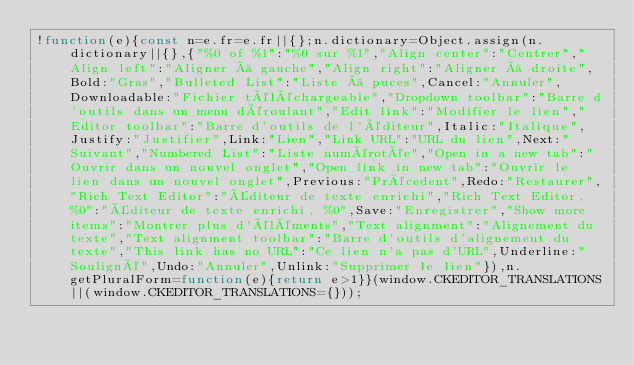<code> <loc_0><loc_0><loc_500><loc_500><_JavaScript_>!function(e){const n=e.fr=e.fr||{};n.dictionary=Object.assign(n.dictionary||{},{"%0 of %1":"%0 sur %1","Align center":"Centrer","Align left":"Aligner à gauche","Align right":"Aligner à droite",Bold:"Gras","Bulleted List":"Liste à puces",Cancel:"Annuler",Downloadable:"Fichier téléchargeable","Dropdown toolbar":"Barre d'outils dans un menu déroulant","Edit link":"Modifier le lien","Editor toolbar":"Barre d'outils de l'éditeur",Italic:"Italique",Justify:"Justifier",Link:"Lien","Link URL":"URL du lien",Next:"Suivant","Numbered List":"Liste numérotée","Open in a new tab":"Ouvrir dans un nouvel onglet","Open link in new tab":"Ouvrir le lien dans un nouvel onglet",Previous:"Précedent",Redo:"Restaurer","Rich Text Editor":"Éditeur de texte enrichi","Rich Text Editor, %0":"Éditeur de texte enrichi, %0",Save:"Enregistrer","Show more items":"Montrer plus d'éléments","Text alignment":"Alignement du texte","Text alignment toolbar":"Barre d'outils d'alignement du texte","This link has no URL":"Ce lien n'a pas d'URL",Underline:"Souligné",Undo:"Annuler",Unlink:"Supprimer le lien"}),n.getPluralForm=function(e){return e>1}}(window.CKEDITOR_TRANSLATIONS||(window.CKEDITOR_TRANSLATIONS={}));</code> 